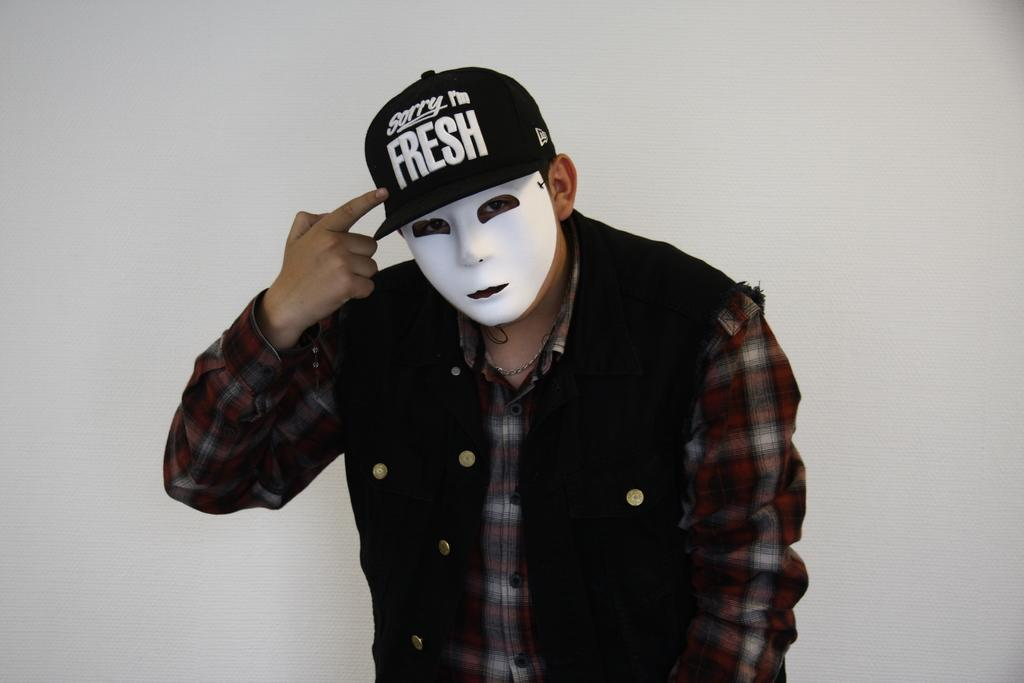Who is present in the image? There is a man in the image. What is the man wearing on his face? The man is wearing a mask. What color is the jacket the man is wearing? The man is wearing a black jacket. What type of headwear is the man wearing? The man is wearing a cap. What can be seen in the background of the image? There is a wall in the background of the image. What type of pig is visible in the image? There is no pig present in the image. What is the man using to balance the yoke on his shoulders in the image? There is no yoke or balancing activity depicted in the image. 